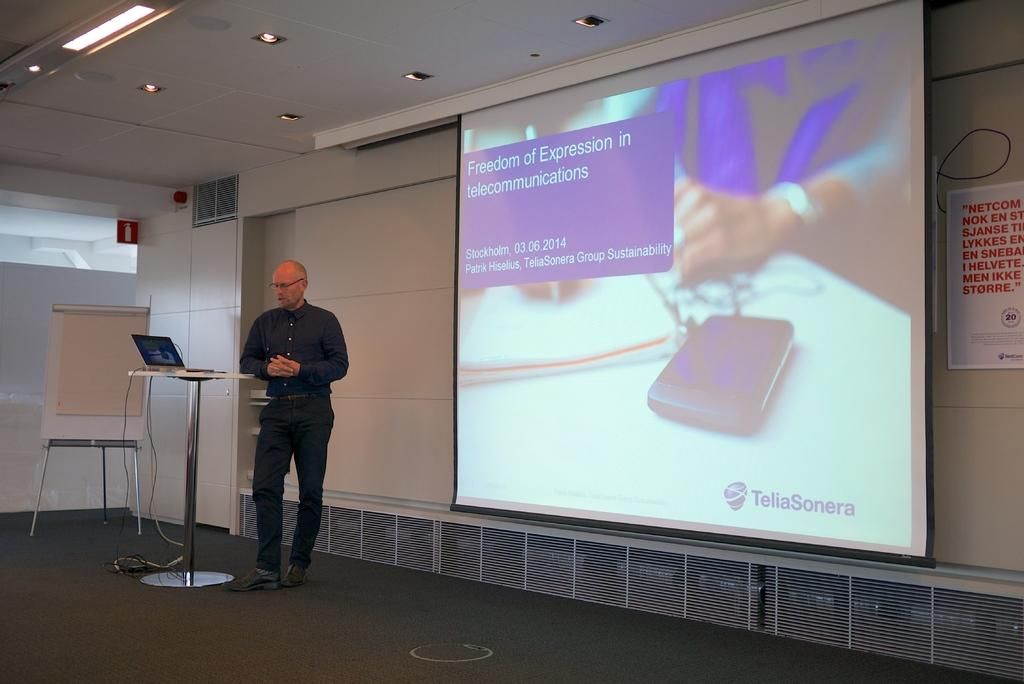What type of structure can be seen in the image? There is a wall in the image. What device is present in the image? There is a screen in the image. What can be seen illuminating the area in the image? There are lights in the image. What is the person in the image wearing? The person in the image is wearing a black color shirt. What electronic device is visible in the image? There is a laptop in the image. What is the minister's temper like in the image? There is no minister present in the image, so it is not possible to determine their temper. 